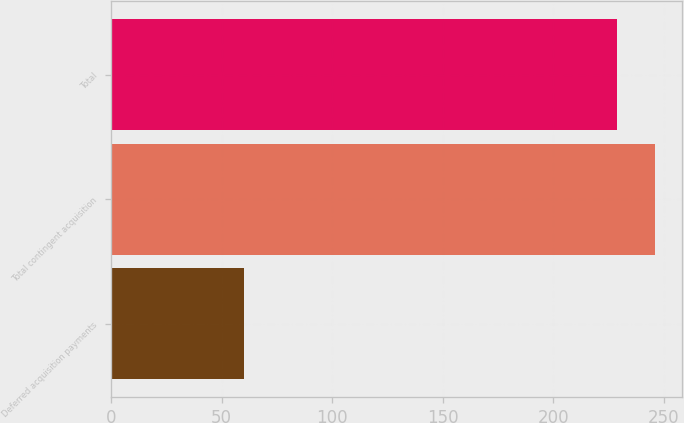<chart> <loc_0><loc_0><loc_500><loc_500><bar_chart><fcel>Deferred acquisition payments<fcel>Total contingent acquisition<fcel>Total<nl><fcel>60<fcel>246.14<fcel>228.9<nl></chart> 